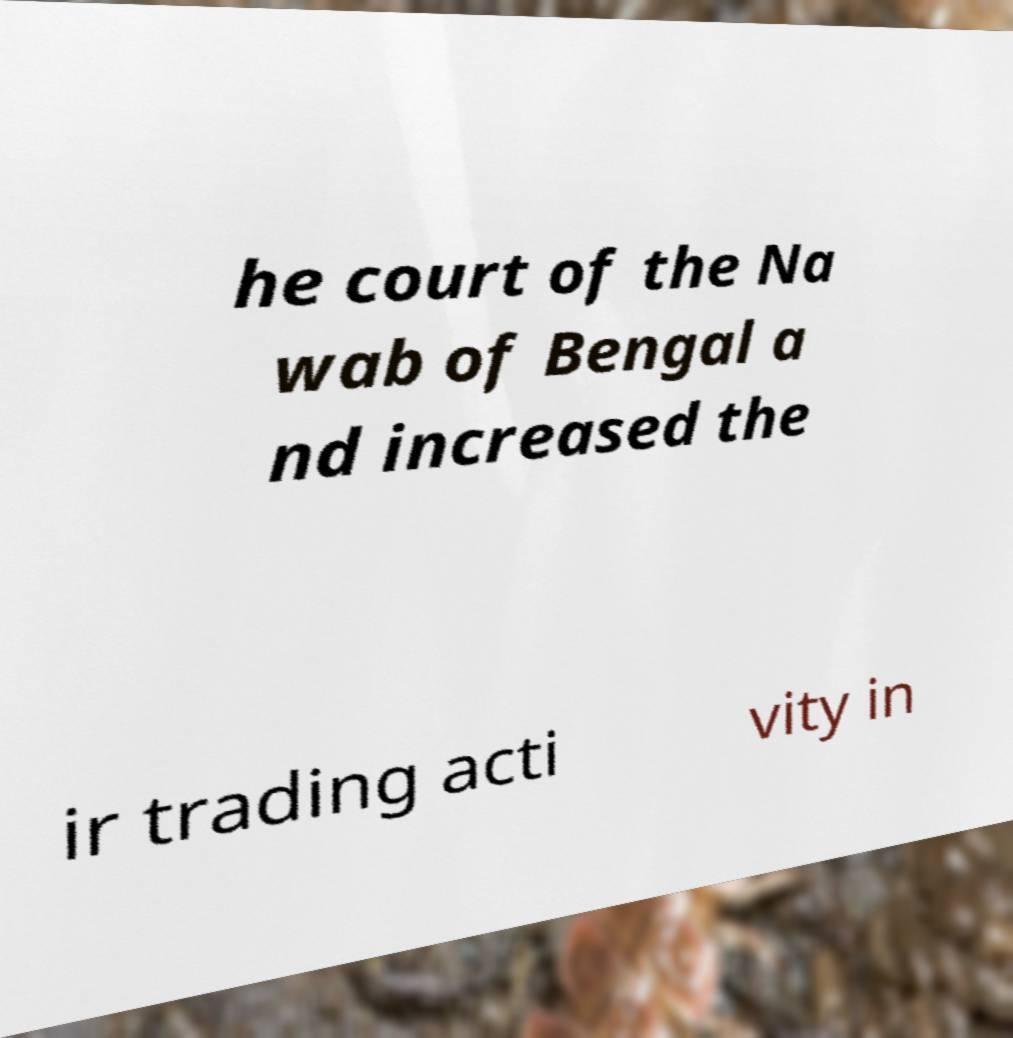I need the written content from this picture converted into text. Can you do that? he court of the Na wab of Bengal a nd increased the ir trading acti vity in 